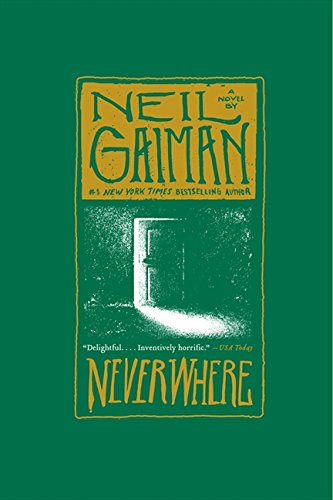What can readers expect in terms of themes from this book? Readers can explore themes of existentialism, the juxtaposition of two worlds, and the exploration of societal structures through the eyes of the protagonist as he navigates the murky and often perilous landscape of London Below. 